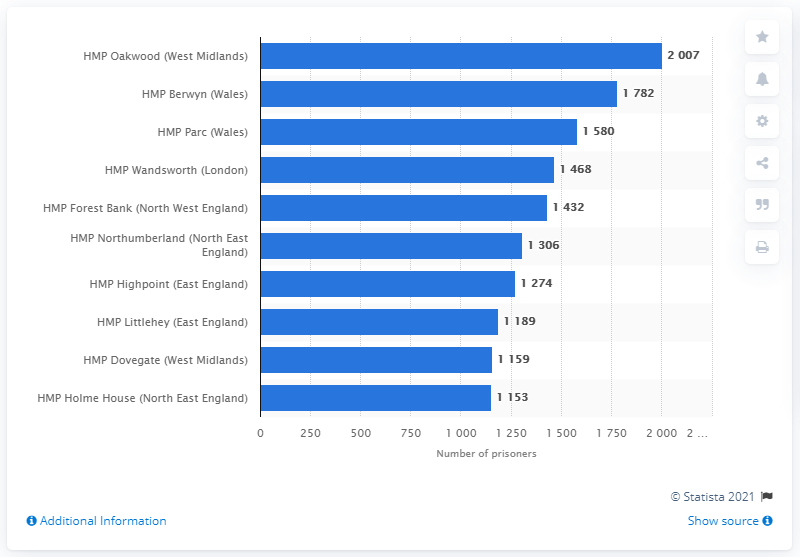Draw attention to some important aspects in this diagram. The number of prisoners held at HMP Oakwood in the year 2020 was 2007. 